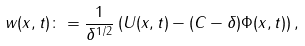Convert formula to latex. <formula><loc_0><loc_0><loc_500><loc_500>w ( x , t ) \colon = \frac { 1 } { \delta ^ { 1 / 2 } } \left ( U ( x , t ) - ( C - \delta ) \Phi ( x , t ) \right ) ,</formula> 